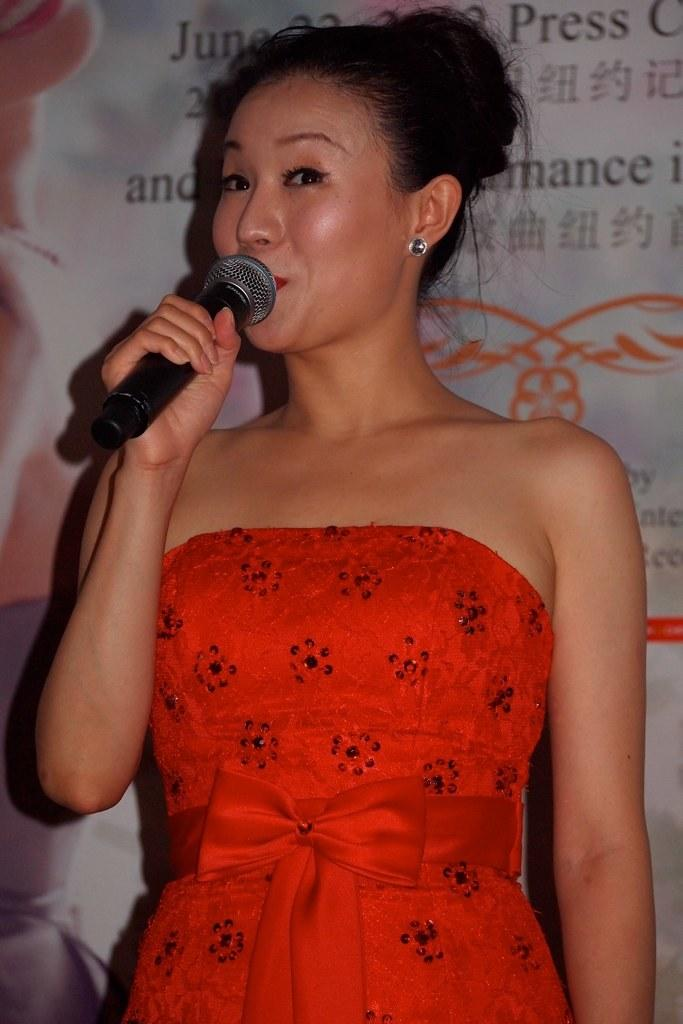Who is the main subject in the image? There is a lady in the image. What is the lady wearing? The lady is wearing a red dress. What is the lady holding in the image? The lady is holding a microphone. What is the lady's posture in the image? The lady is standing. What can be seen in the background of the image? There is a board in the background of the image. Where might this image have been taken? The image appears to be taken inside a hall. What type of animals can be seen at the market in the image? There is no market or animals present in the image; it features a lady holding a microphone inside a hall. 